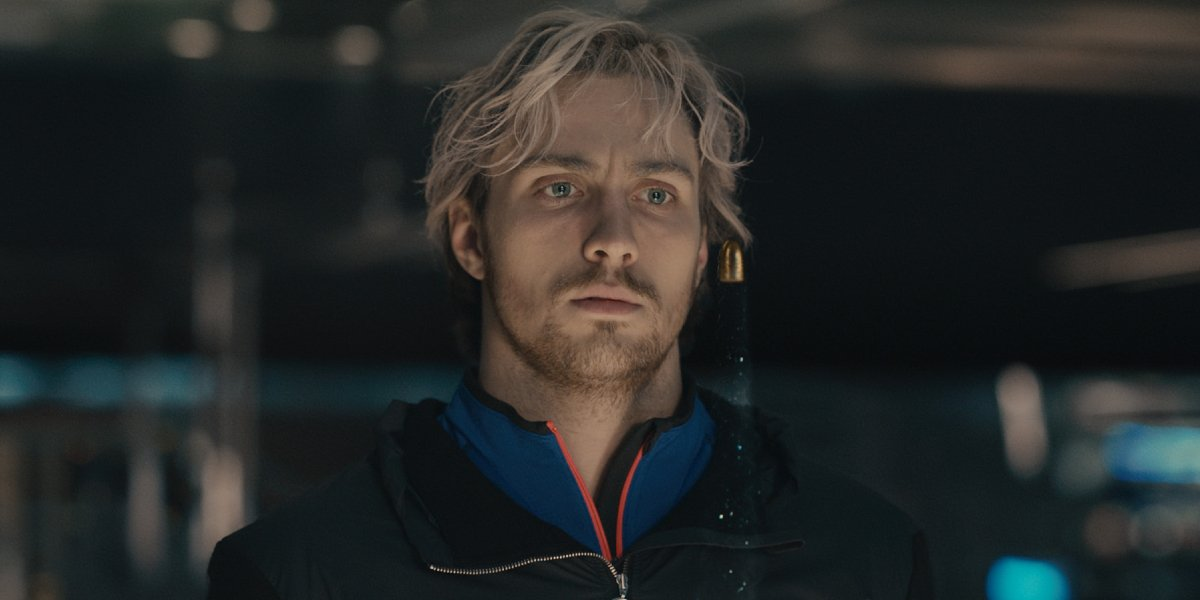Imagine this scene is from a movie. Write the next lines of dialogue that could follow. In a low, calm voice, the man mutters to himself: 'I hope today brings the answers I've been searching for.' Just then, a familiar voice calls out from behind, 'Hey, thought I'd find you here.' He turns around, his expression softening slightly, to see an old friend walking towards him, a look of shared understanding on their face. 